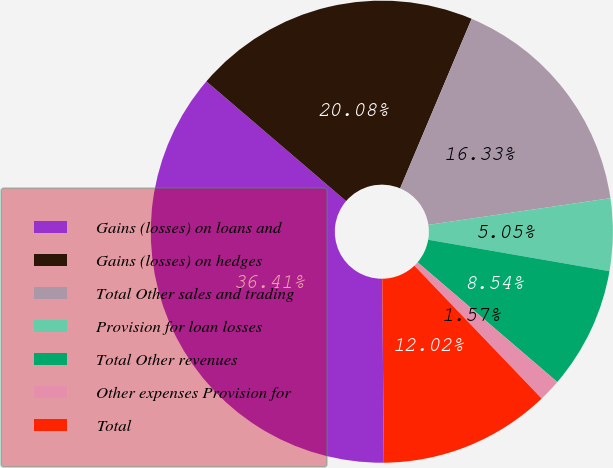<chart> <loc_0><loc_0><loc_500><loc_500><pie_chart><fcel>Gains (losses) on loans and<fcel>Gains (losses) on hedges<fcel>Total Other sales and trading<fcel>Provision for loan losses<fcel>Total Other revenues<fcel>Other expenses Provision for<fcel>Total<nl><fcel>36.41%<fcel>20.08%<fcel>16.33%<fcel>5.05%<fcel>8.54%<fcel>1.57%<fcel>12.02%<nl></chart> 